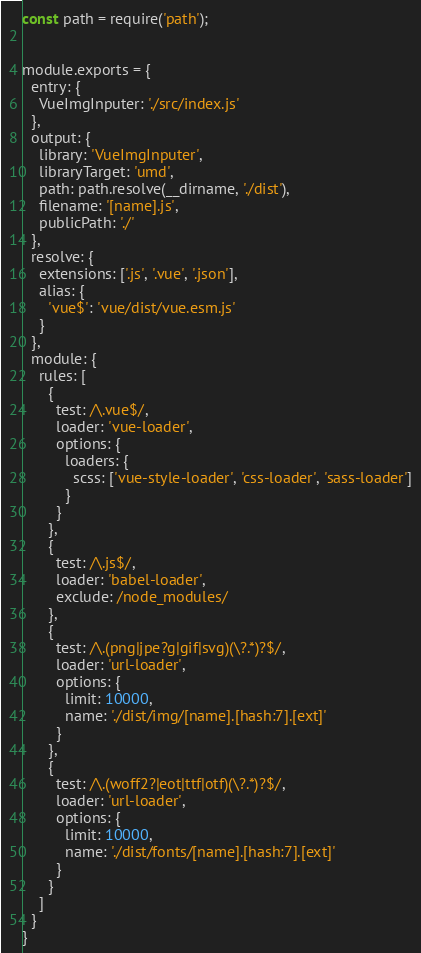Convert code to text. <code><loc_0><loc_0><loc_500><loc_500><_JavaScript_>const path = require('path');


module.exports = {
  entry: {
    VueImgInputer: './src/index.js'
  },
  output: {
    library: 'VueImgInputer',
    libraryTarget: 'umd',
    path: path.resolve(__dirname, './dist'),
    filename: '[name].js',
    publicPath: './'
  },
  resolve: {
    extensions: ['.js', '.vue', '.json'],
    alias: {
      'vue$': 'vue/dist/vue.esm.js'
    }
  },
  module: {
    rules: [
      {
        test: /\.vue$/,
        loader: 'vue-loader',
        options: {
          loaders: {
            scss: ['vue-style-loader', 'css-loader', 'sass-loader']
          }
        }
      },
      {
        test: /\.js$/,
        loader: 'babel-loader',
        exclude: /node_modules/
      },
      {
        test: /\.(png|jpe?g|gif|svg)(\?.*)?$/,
        loader: 'url-loader',
        options: {
          limit: 10000,
          name: './dist/img/[name].[hash:7].[ext]'
        }
      },
      {
        test: /\.(woff2?|eot|ttf|otf)(\?.*)?$/,
        loader: 'url-loader',
        options: {
          limit: 10000,
          name: './dist/fonts/[name].[hash:7].[ext]'
        }
      }
    ]
  }
}
</code> 